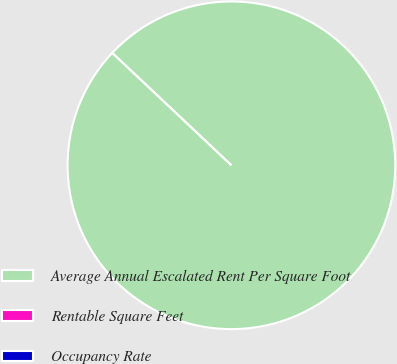<chart> <loc_0><loc_0><loc_500><loc_500><pie_chart><fcel>Average Annual Escalated Rent Per Square Foot<fcel>Rentable Square Feet<fcel>Occupancy Rate<nl><fcel>100.0%<fcel>0.0%<fcel>0.0%<nl></chart> 